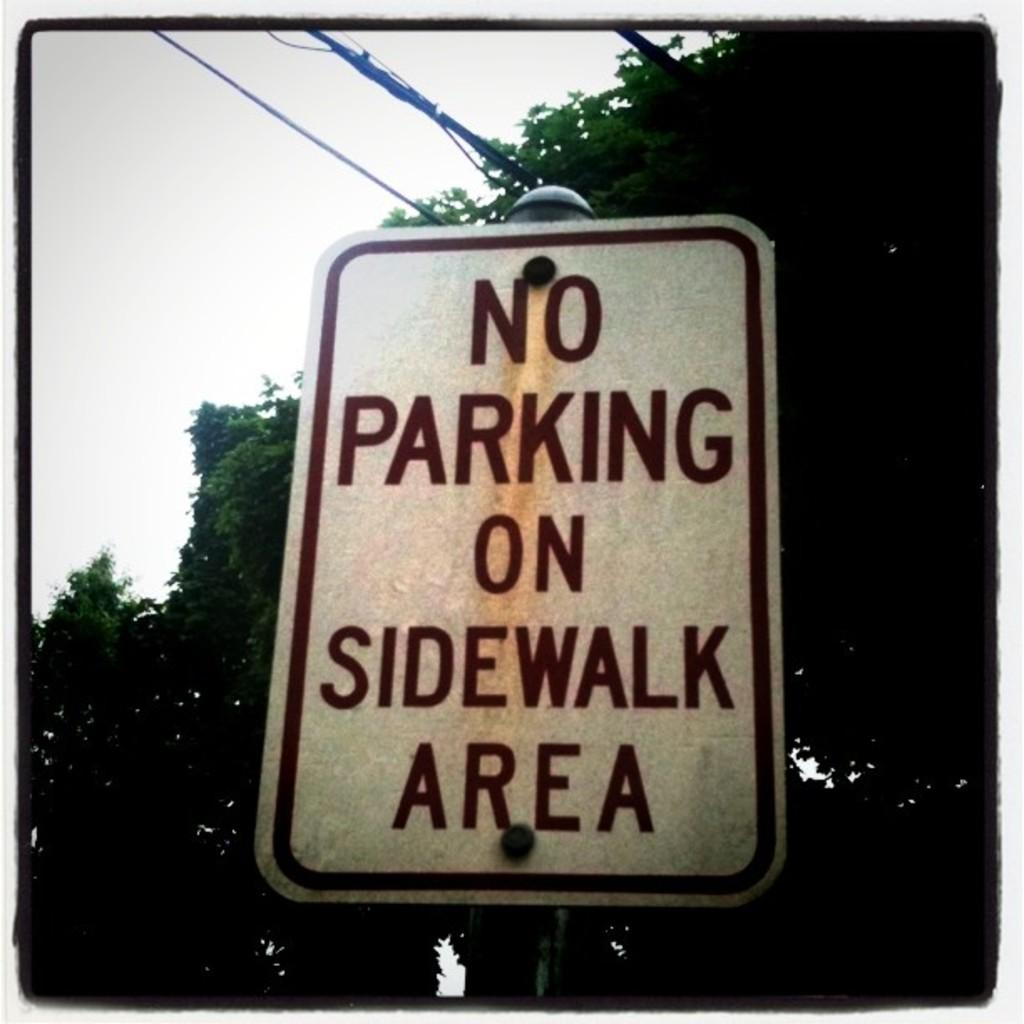<image>
Offer a succinct explanation of the picture presented. A sign informs people to not park on the sidewalk area. 